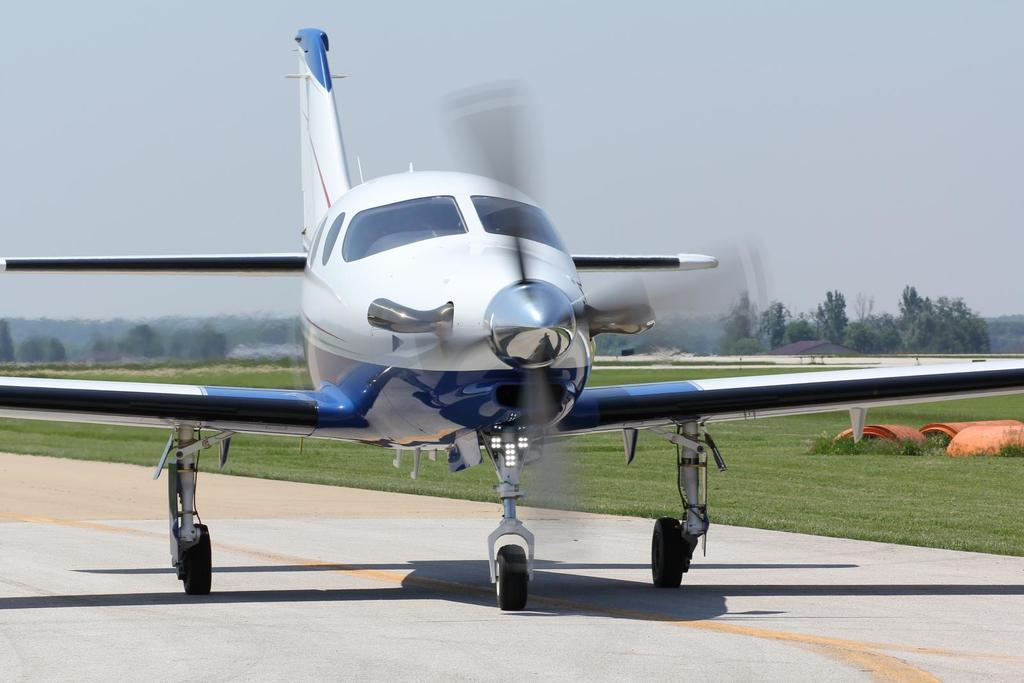What is the unusual object on the road in the image? There is an aeroplane on the road in the image. What can be seen on the right side of the image in the background? There are objects on the right side on the grass in the background. What type of natural scenery is visible in the background? There are trees visible in the background. What part of the natural environment is visible in the image? The sky is visible in the background. Where is the office located in the image? There is no office present in the image. What type of water feature can be seen in the image? There is no water feature present in the image. 